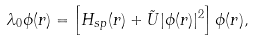Convert formula to latex. <formula><loc_0><loc_0><loc_500><loc_500>\lambda _ { 0 } \phi ( r ) = \left [ H _ { s p } ( r ) + \tilde { U } | \phi ( r ) | ^ { 2 } \right ] \phi ( r ) ,</formula> 